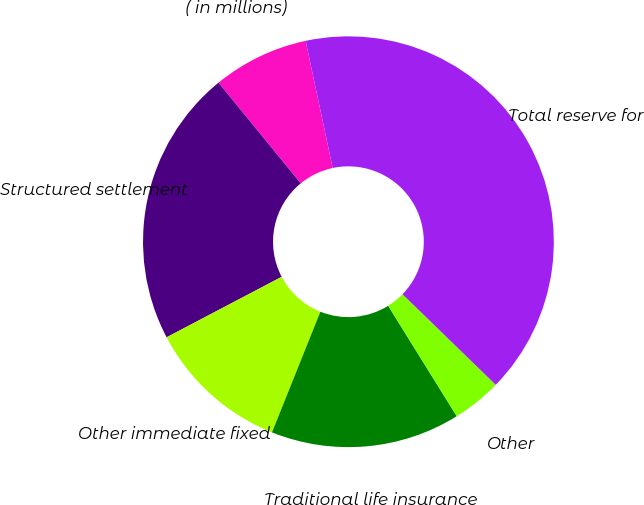Convert chart. <chart><loc_0><loc_0><loc_500><loc_500><pie_chart><fcel>( in millions)<fcel>Structured settlement<fcel>Other immediate fixed<fcel>Traditional life insurance<fcel>Other<fcel>Total reserve for<nl><fcel>7.56%<fcel>21.8%<fcel>11.23%<fcel>14.91%<fcel>3.89%<fcel>40.61%<nl></chart> 